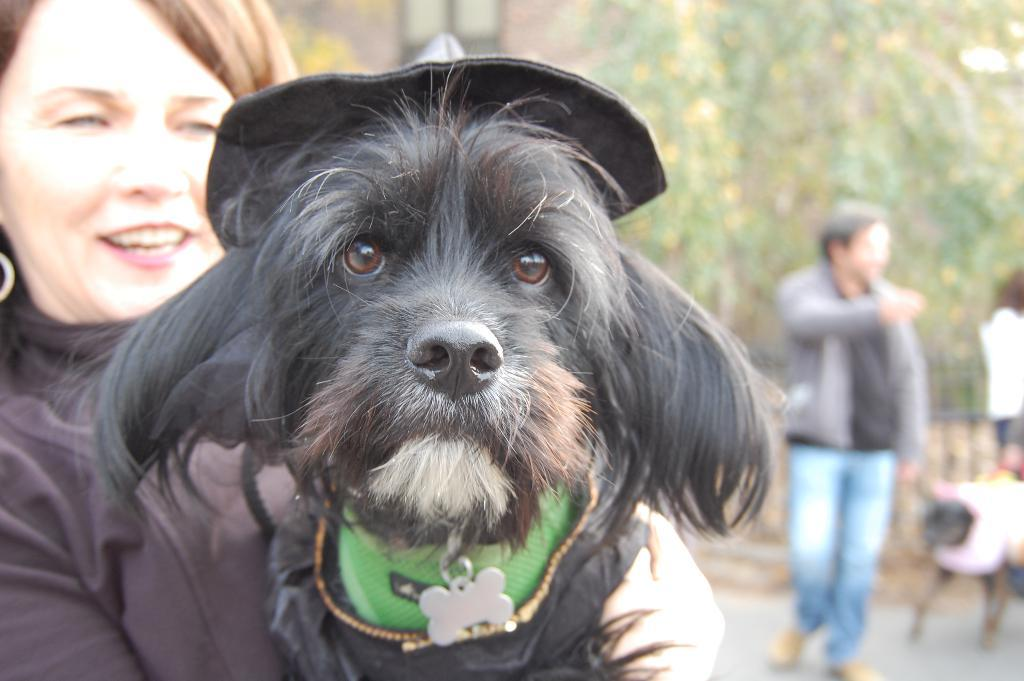Who is present in the image? There is a woman in the image. What is the woman doing in the image? The woman is smiling and holding a dog. Can you describe the dog in the image? The dog is wearing a hat. What else can be seen in the background of the image? There is a man in the background of the image, and he is walking with another dog. What type of vegetation is visible in the background? There are trees visible in the background of the image. What is the temperature of the sea in the image? There is no sea present in the image, so it is not possible to determine the temperature. 